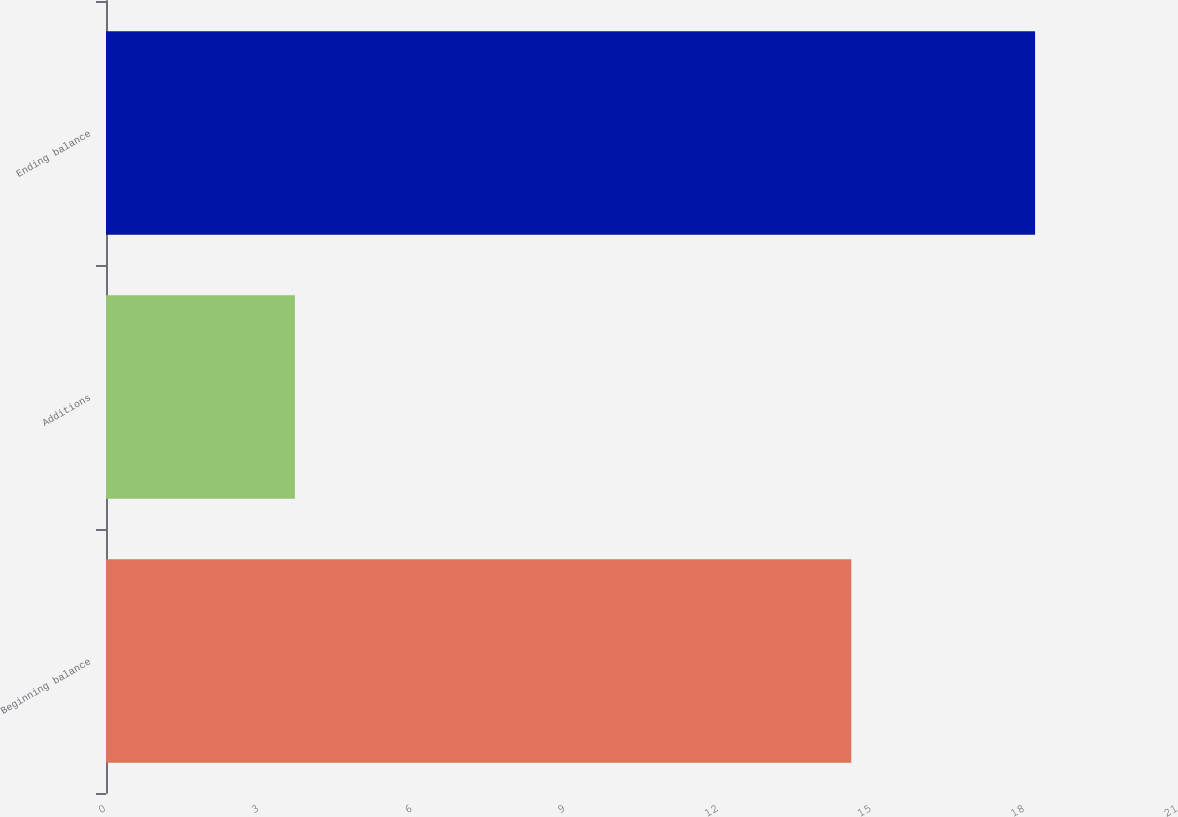Convert chart to OTSL. <chart><loc_0><loc_0><loc_500><loc_500><bar_chart><fcel>Beginning balance<fcel>Additions<fcel>Ending balance<nl><fcel>14.6<fcel>3.7<fcel>18.2<nl></chart> 